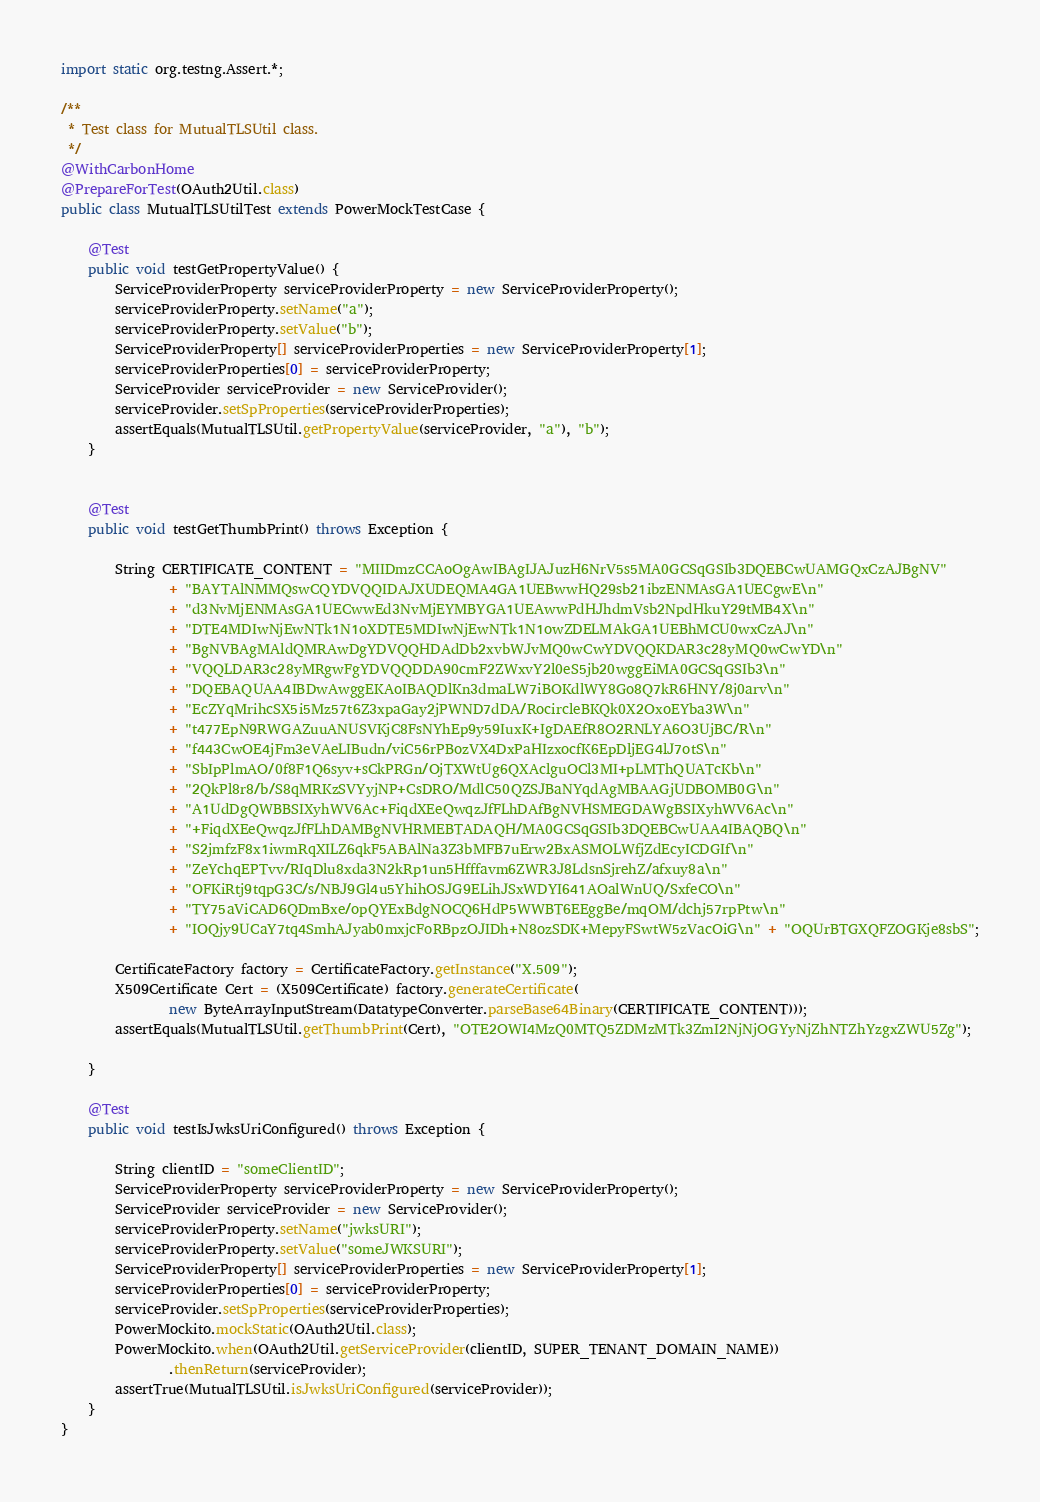<code> <loc_0><loc_0><loc_500><loc_500><_Java_>import static org.testng.Assert.*;

/**
 * Test class for MutualTLSUtil class.
 */
@WithCarbonHome
@PrepareForTest(OAuth2Util.class)
public class MutualTLSUtilTest extends PowerMockTestCase {

    @Test
    public void testGetPropertyValue() {
        ServiceProviderProperty serviceProviderProperty = new ServiceProviderProperty();
        serviceProviderProperty.setName("a");
        serviceProviderProperty.setValue("b");
        ServiceProviderProperty[] serviceProviderProperties = new ServiceProviderProperty[1];
        serviceProviderProperties[0] = serviceProviderProperty;
        ServiceProvider serviceProvider = new ServiceProvider();
        serviceProvider.setSpProperties(serviceProviderProperties);
        assertEquals(MutualTLSUtil.getPropertyValue(serviceProvider, "a"), "b");
    }


    @Test
    public void testGetThumbPrint() throws Exception {

        String CERTIFICATE_CONTENT = "MIIDmzCCAoOgAwIBAgIJAJuzH6NrV5s5MA0GCSqGSIb3DQEBCwUAMGQxCzAJBgNV"
                + "BAYTAlNMMQswCQYDVQQIDAJXUDEQMA4GA1UEBwwHQ29sb21ibzENMAsGA1UECgwE\n"
                + "d3NvMjENMAsGA1UECwwEd3NvMjEYMBYGA1UEAwwPdHJhdmVsb2NpdHkuY29tMB4X\n"
                + "DTE4MDIwNjEwNTk1N1oXDTE5MDIwNjEwNTk1N1owZDELMAkGA1UEBhMCU0wxCzAJ\n"
                + "BgNVBAgMAldQMRAwDgYDVQQHDAdDb2xvbWJvMQ0wCwYDVQQKDAR3c28yMQ0wCwYD\n"
                + "VQQLDAR3c28yMRgwFgYDVQQDDA90cmF2ZWxvY2l0eS5jb20wggEiMA0GCSqGSIb3\n"
                + "DQEBAQUAA4IBDwAwggEKAoIBAQDlKn3dmaLW7iBOKdlWY8Go8Q7kR6HNY/8j0arv\n"
                + "EcZYqMrihcSX5i5Mz57t6Z3xpaGay2jPWND7dDA/RocircleBKQk0X2OxoEYba3W\n"
                + "t477EpN9RWGAZuuANUSVKjC8FsNYhEp9y59IuxK+IgDAEfR8O2RNLYA6O3UjBC/R\n"
                + "f443CwOE4jFm3eVAeLIBudn/viC56rPBozVX4DxPaHIzxocfK6EpDljEG4lJ7otS\n"
                + "SbIpPlmAO/0f8F1Q6syv+sCkPRGn/OjTXWtUg6QXAclguOCl3MI+pLMThQUATcKb\n"
                + "2QkPl8r8/b/S8qMRKzSVYyjNP+CsDRO/MdlC50QZSJBaNYqdAgMBAAGjUDBOMB0G\n"
                + "A1UdDgQWBBSIXyhWV6Ac+FiqdXEeQwqzJfFLhDAfBgNVHSMEGDAWgBSIXyhWV6Ac\n"
                + "+FiqdXEeQwqzJfFLhDAMBgNVHRMEBTADAQH/MA0GCSqGSIb3DQEBCwUAA4IBAQBQ\n"
                + "S2jmfzF8x1iwmRqXILZ6qkF5ABAlNa3Z3bMFB7uErw2BxASMOLWfjZdEcyICDGIf\n"
                + "ZeYchqEPTvv/RIqDlu8xda3N2kRp1un5Hfffavm6ZWR3J8LdsnSjrehZ/afxuy8a\n"
                + "OFKiRtj9tqpG3C/s/NBJ9Gl4u5YhihOSJG9ELihJSxWDYI641AOalWnUQ/SxfeCO\n"
                + "TY75aViCAD6QDmBxe/opQYExBdgNOCQ6HdP5WWBT6EEggBe/mqOM/dchj57rpPtw\n"
                + "IOQjy9UCaY7tq4SmhAJyab0mxjcFoRBpzOJIDh+N8ozSDK+MepyFSwtW5zVacOiG\n" + "OQUrBTGXQFZOGKje8sbS";

        CertificateFactory factory = CertificateFactory.getInstance("X.509");
        X509Certificate Cert = (X509Certificate) factory.generateCertificate(
                new ByteArrayInputStream(DatatypeConverter.parseBase64Binary(CERTIFICATE_CONTENT)));
        assertEquals(MutualTLSUtil.getThumbPrint(Cert), "OTE2OWI4MzQ0MTQ5ZDMzMTk3ZmI2NjNjOGYyNjZhNTZhYzgxZWU5Zg");

    }

    @Test
    public void testIsJwksUriConfigured() throws Exception {

        String clientID = "someClientID";
        ServiceProviderProperty serviceProviderProperty = new ServiceProviderProperty();
        ServiceProvider serviceProvider = new ServiceProvider();
        serviceProviderProperty.setName("jwksURI");
        serviceProviderProperty.setValue("someJWKSURI");
        ServiceProviderProperty[] serviceProviderProperties = new ServiceProviderProperty[1];
        serviceProviderProperties[0] = serviceProviderProperty;
        serviceProvider.setSpProperties(serviceProviderProperties);
        PowerMockito.mockStatic(OAuth2Util.class);
        PowerMockito.when(OAuth2Util.getServiceProvider(clientID, SUPER_TENANT_DOMAIN_NAME))
                .thenReturn(serviceProvider);
        assertTrue(MutualTLSUtil.isJwksUriConfigured(serviceProvider));
    }
}</code> 